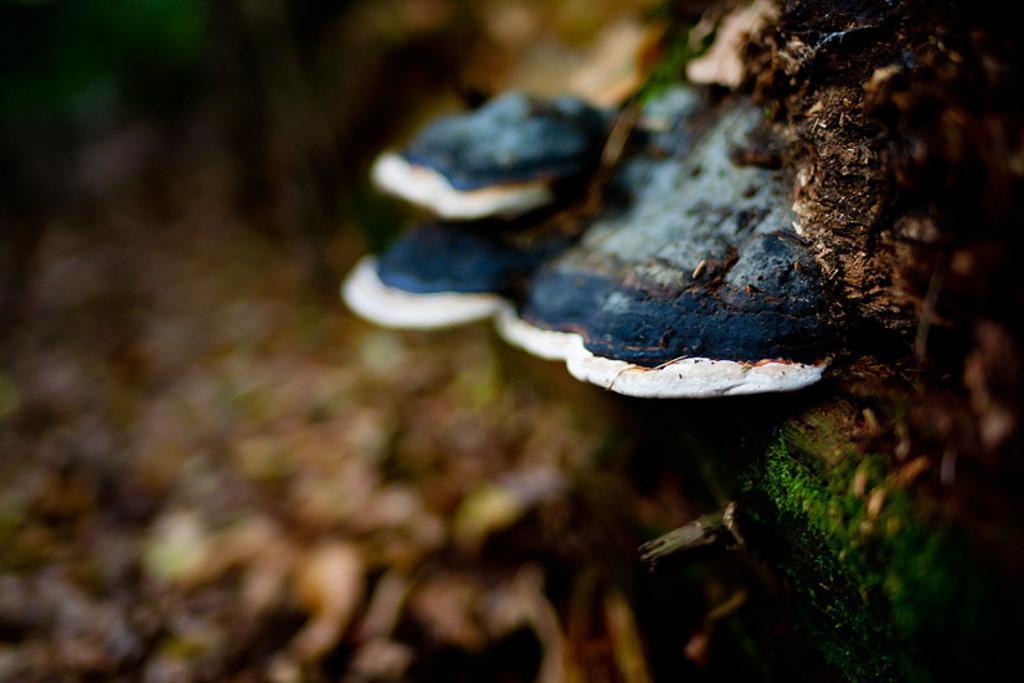How would you summarize this image in a sentence or two? In the center of the image we can see mushrooms, which is in white and blue color and we can see a few other objects. In the background we can see it is blurred. 